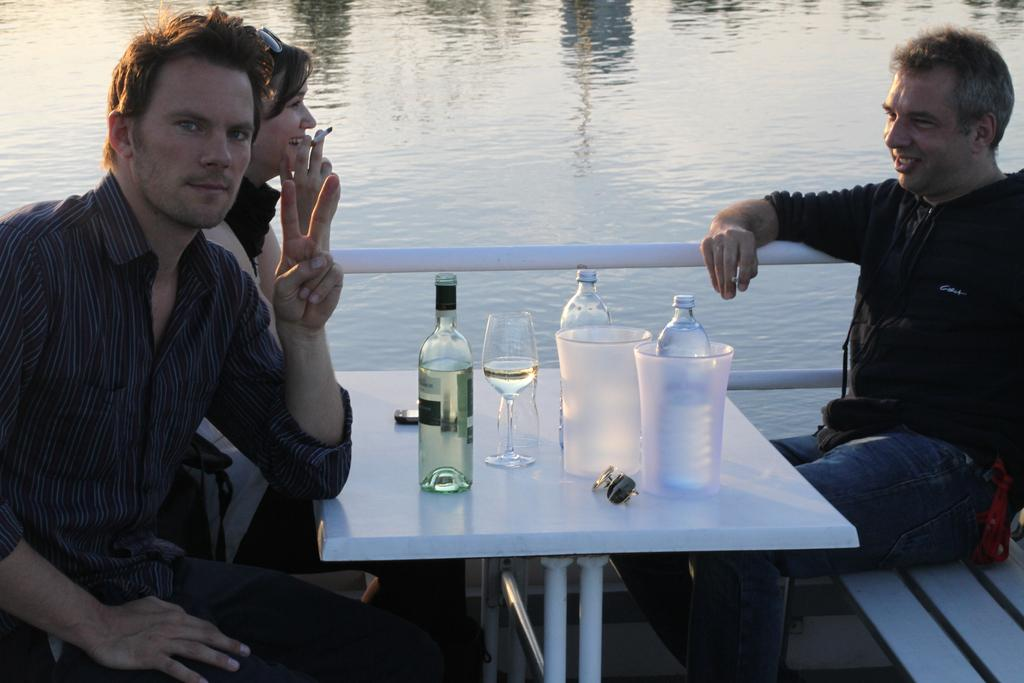What are the persons in the image doing? The persons in the image are sitting on a chair. What can be seen on the table in the image? There is a glass, bottles, a mobile, and a container on the table. What type of water is visible in the image? The image depicts a freshwater river. How many cattle can be seen grazing near the freshwater river in the image? There are no cattle present in the image; it only depicts a freshwater river and the objects on the table. 